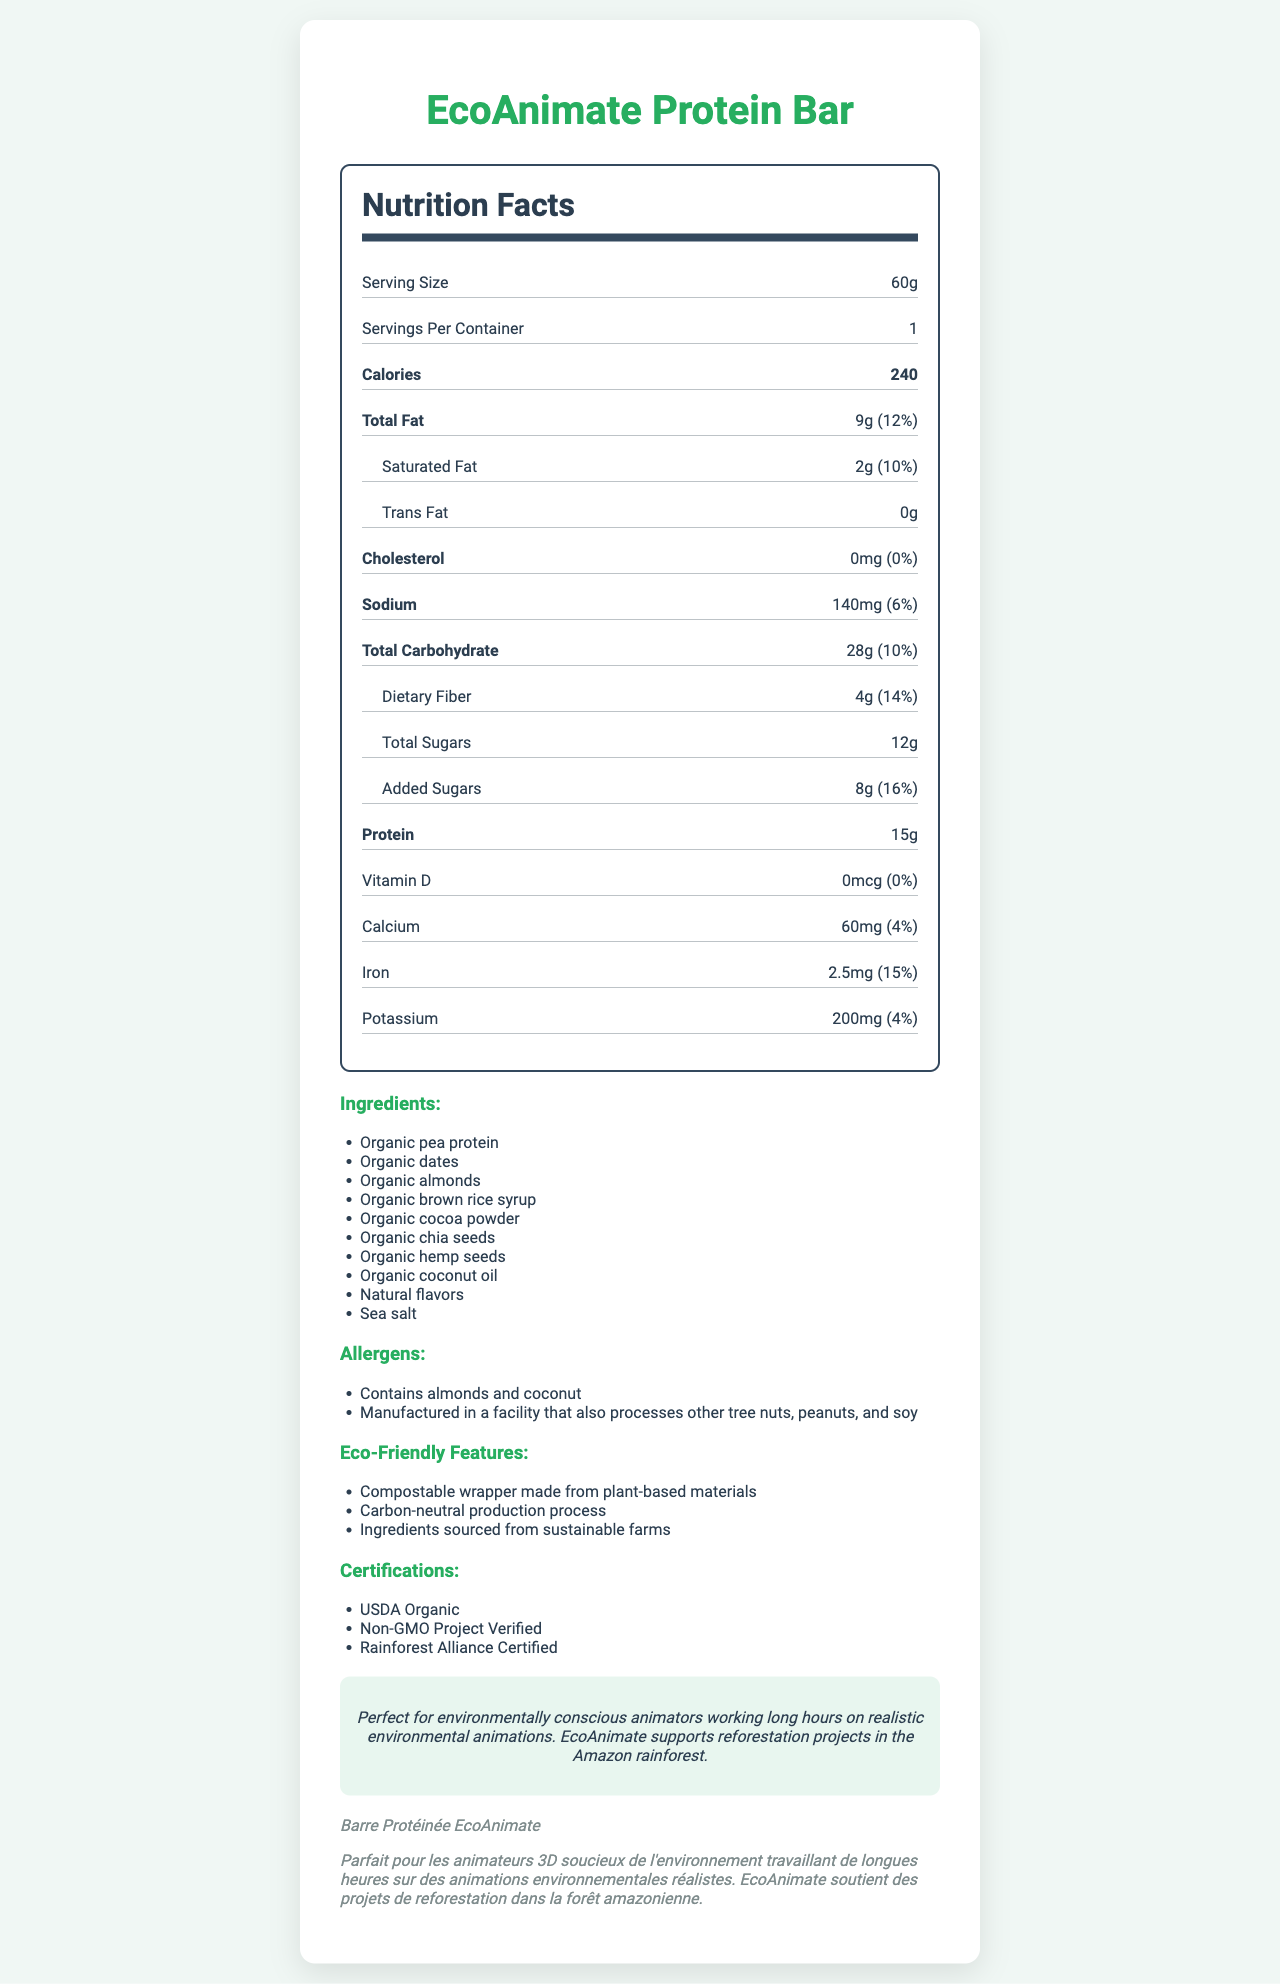what is the serving size? The document lists the serving size of the EcoAnimate Protein Bar as 60g.
Answer: 60g how many calories are in one serving? The document indicates that there are 240 calories per serving.
Answer: 240 what is the total fat content? The document states the total fat content is 9g.
Answer: 9g what percentage of the daily value is the saturated fat content? The document specifies that the saturated fat content is 2g, which is 10% of the daily value.
Answer: 10% what is the sodium content in mg? The document indicates that the sodium content is 140mg.
Answer: 140mg which of the following is not an ingredient in the EcoAnimate Protein Bar? A. Organic peas B. Organic dates C. Organic almonds D. Organic chia seeds The document lists "Organic pea protein" but not "Organic peas."
Answer: A what is the potassium content? A. 60mg B. 140mg C. 200mg D. 2.5mg The document lists the potassium content as 200mg.
Answer: C does the EcoAnimate Protein Bar contain any trans fat? The document specifies that the trans fat content is 0g.
Answer: No briefly describe the eco-friendly features of the EcoAnimate Protein Bar. The document mentions that the bar has a compostable wrapper made from plant-based materials, a carbon-neutral production process, and ingredients sourced from sustainable farms.
Answer: Compostable wrapper, Carbon-neutral production, Sustainable ingredient sourcing how much protein is in a single serving of the EcoAnimate Protein Bar? The document states that there are 15g of protein per serving.
Answer: 15g does the EcoAnimate Protein Bar contain any added sugars? The document states that the bar contains 8g of added sugars.
Answer: Yes what is the price of the EcoAnimate Protein Bar? The document does not provide any information about the price.
Answer: I don't know does the EcoAnimate Protein Bar support any environmental projects? The document includes a sustainability message stating that EcoAnimate supports reforestation projects in the Amazon rainforest.
Answer: Yes what certifications does the EcoAnimate Protein Bar have? The document lists three certifications: USDA Organic, Non-GMO Project Verified, and Rainforest Alliance Certified.
Answer: USDA Organic, Non-GMO Project Verified, Rainforest Alliance Certified summarize the main idea of the document. The document outlines the nutritional content, ingredients, associated allergens, eco-friendly traits, certifications, and the sustainability message of the EcoAnimate Protein Bar, emphasizing its alignment with environmentally conscious values.
Answer: The document provides detailed nutrition facts, ingredients, allergens, eco-friendly features, certifications, and a sustainability message for the EcoAnimate Protein Bar. 